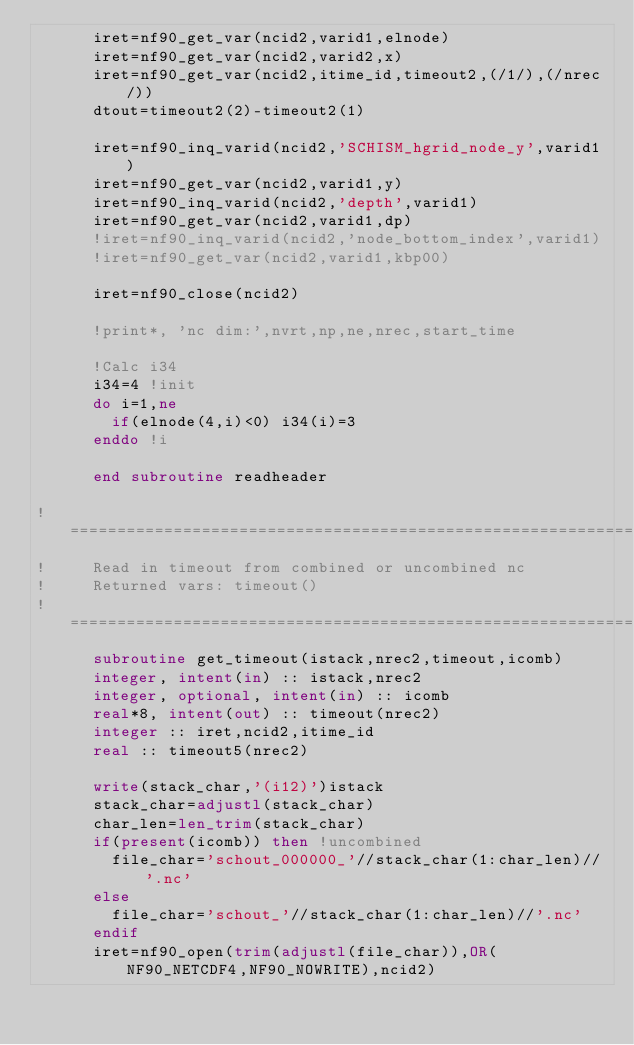<code> <loc_0><loc_0><loc_500><loc_500><_FORTRAN_>      iret=nf90_get_var(ncid2,varid1,elnode)
      iret=nf90_get_var(ncid2,varid2,x)
      iret=nf90_get_var(ncid2,itime_id,timeout2,(/1/),(/nrec/))
      dtout=timeout2(2)-timeout2(1)

      iret=nf90_inq_varid(ncid2,'SCHISM_hgrid_node_y',varid1)
      iret=nf90_get_var(ncid2,varid1,y)
      iret=nf90_inq_varid(ncid2,'depth',varid1)
      iret=nf90_get_var(ncid2,varid1,dp)
      !iret=nf90_inq_varid(ncid2,'node_bottom_index',varid1)
      !iret=nf90_get_var(ncid2,varid1,kbp00)

      iret=nf90_close(ncid2)

      !print*, 'nc dim:',nvrt,np,ne,nrec,start_time

      !Calc i34
      i34=4 !init
      do i=1,ne
        if(elnode(4,i)<0) i34(i)=3
      enddo !i

      end subroutine readheader

!================================================================
!     Read in timeout from combined or uncombined nc
!     Returned vars: timeout()
!================================================================
      subroutine get_timeout(istack,nrec2,timeout,icomb)
      integer, intent(in) :: istack,nrec2  
      integer, optional, intent(in) :: icomb
      real*8, intent(out) :: timeout(nrec2) 
      integer :: iret,ncid2,itime_id
      real :: timeout5(nrec2)

      write(stack_char,'(i12)')istack
      stack_char=adjustl(stack_char)
      char_len=len_trim(stack_char)
      if(present(icomb)) then !uncombined
        file_char='schout_000000_'//stack_char(1:char_len)//'.nc'
      else
        file_char='schout_'//stack_char(1:char_len)//'.nc'
      endif
      iret=nf90_open(trim(adjustl(file_char)),OR(NF90_NETCDF4,NF90_NOWRITE),ncid2)</code> 